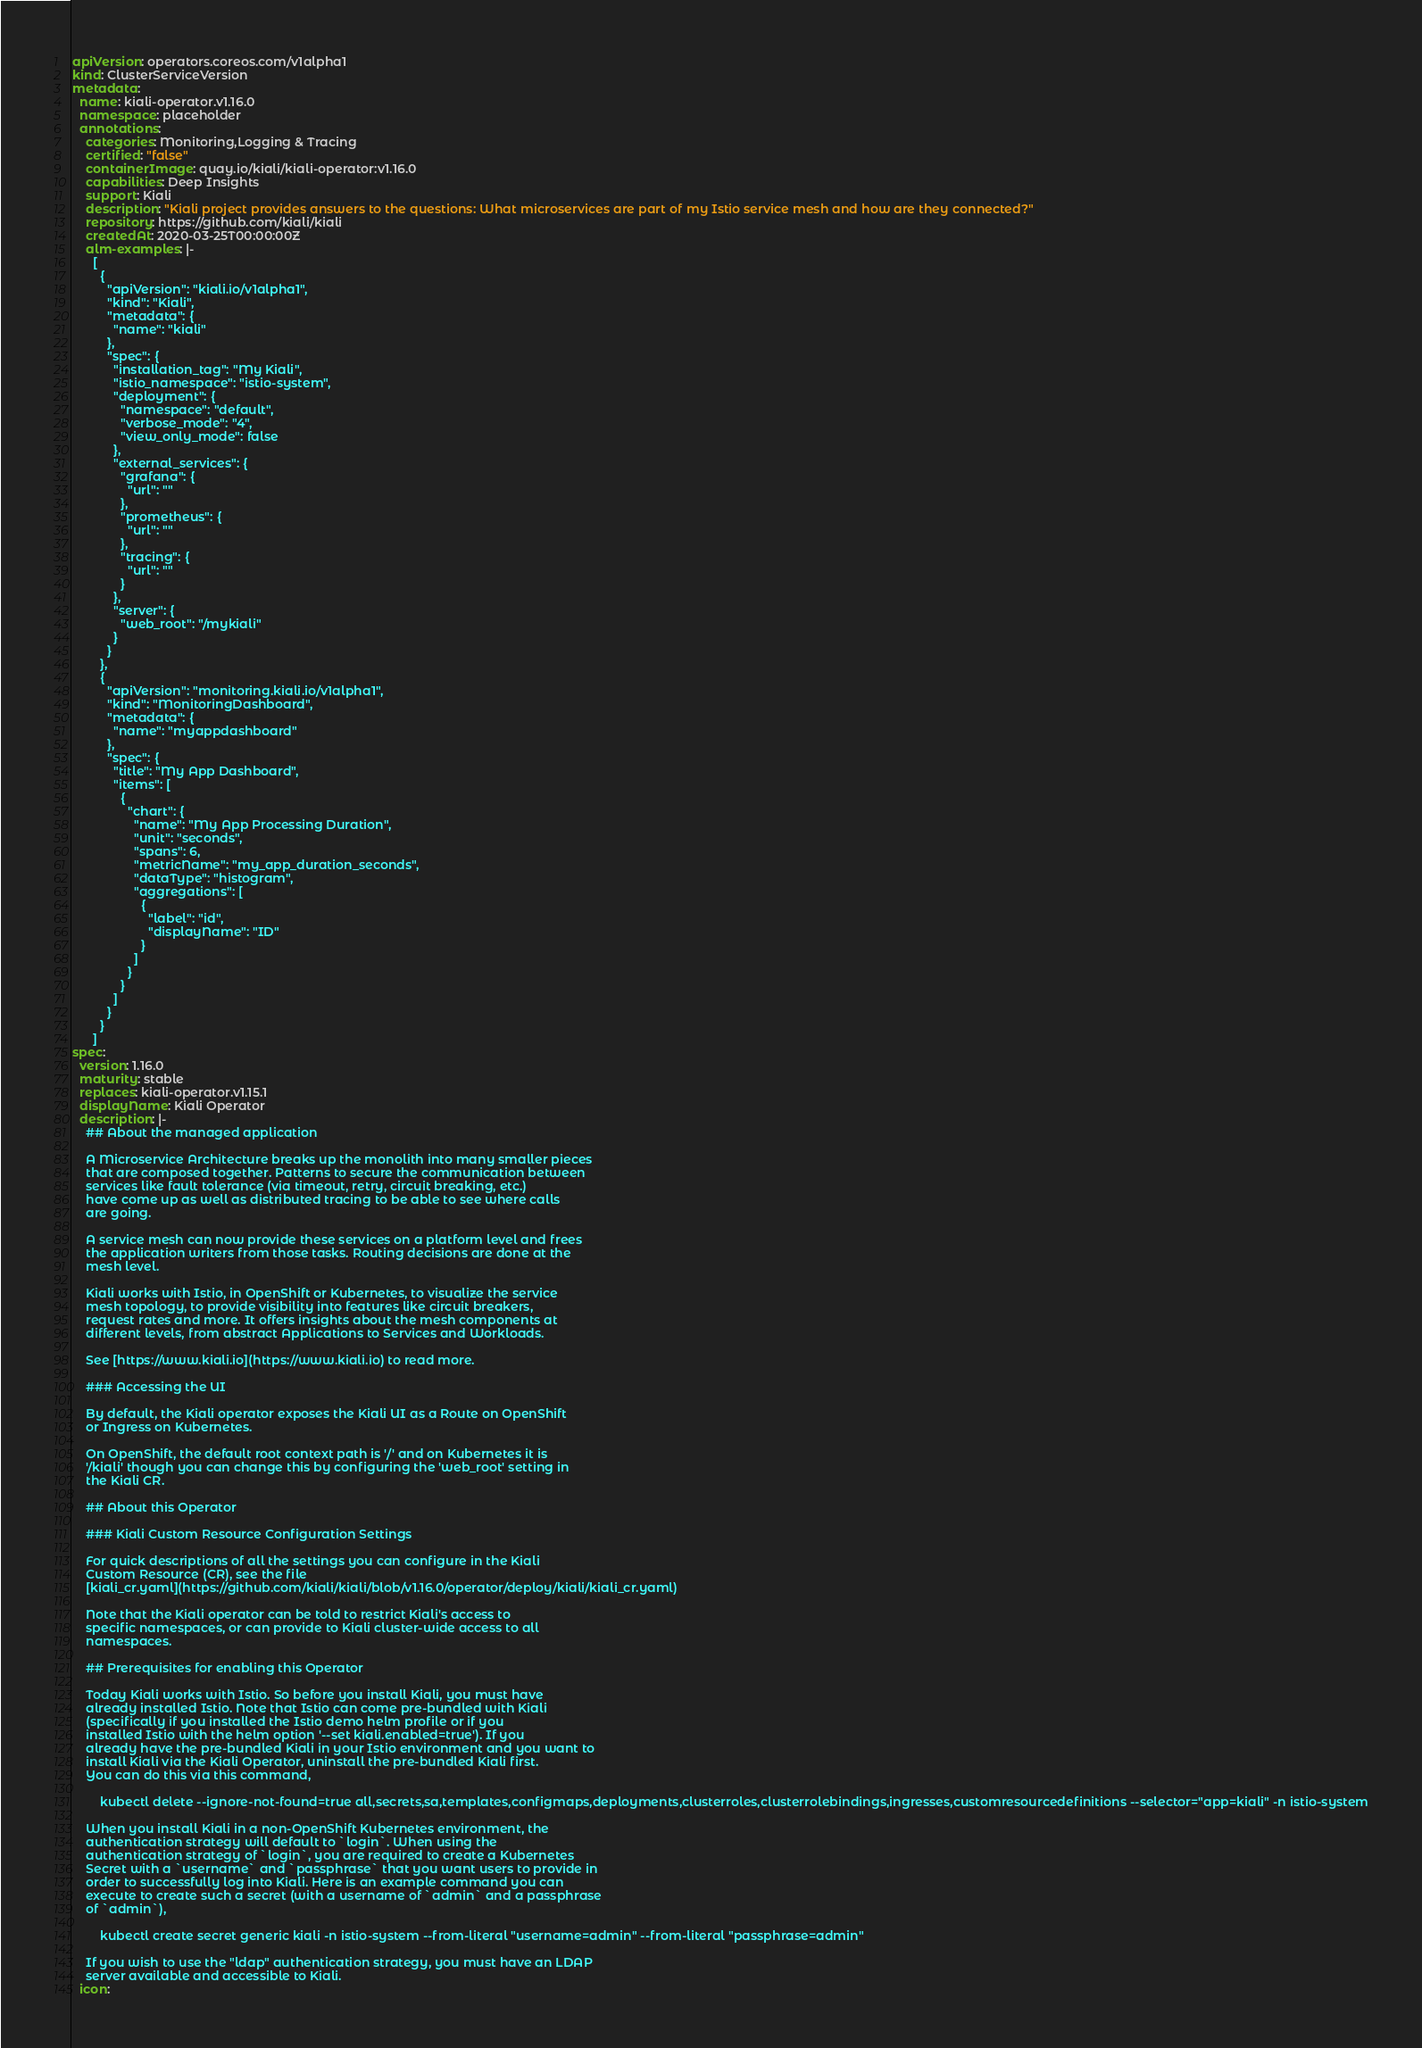Convert code to text. <code><loc_0><loc_0><loc_500><loc_500><_YAML_>apiVersion: operators.coreos.com/v1alpha1
kind: ClusterServiceVersion
metadata:
  name: kiali-operator.v1.16.0
  namespace: placeholder
  annotations:
    categories: Monitoring,Logging & Tracing
    certified: "false"
    containerImage: quay.io/kiali/kiali-operator:v1.16.0
    capabilities: Deep Insights
    support: Kiali
    description: "Kiali project provides answers to the questions: What microservices are part of my Istio service mesh and how are they connected?"
    repository: https://github.com/kiali/kiali
    createdAt: 2020-03-25T00:00:00Z
    alm-examples: |-
      [
        {
          "apiVersion": "kiali.io/v1alpha1",
          "kind": "Kiali",
          "metadata": {
            "name": "kiali"
          },
          "spec": {
            "installation_tag": "My Kiali",
            "istio_namespace": "istio-system",
            "deployment": {
              "namespace": "default",
              "verbose_mode": "4",
              "view_only_mode": false
            },
            "external_services": {
              "grafana": {
                "url": ""
              },
              "prometheus": {
                "url": ""
              },
              "tracing": {
                "url": ""
              }
            },
            "server": {
              "web_root": "/mykiali"
            }
          }
        },
        {
          "apiVersion": "monitoring.kiali.io/v1alpha1",
          "kind": "MonitoringDashboard",
          "metadata": {
            "name": "myappdashboard"
          },
          "spec": {
            "title": "My App Dashboard",
            "items": [
              {
                "chart": {
                  "name": "My App Processing Duration",
                  "unit": "seconds",
                  "spans": 6,
                  "metricName": "my_app_duration_seconds",
                  "dataType": "histogram",
                  "aggregations": [
                    {
                      "label": "id",
                      "displayName": "ID"
                    }
                  ]
                }
              }
            ]
          }
        }
      ]
spec:
  version: 1.16.0
  maturity: stable
  replaces: kiali-operator.v1.15.1
  displayName: Kiali Operator
  description: |-
    ## About the managed application

    A Microservice Architecture breaks up the monolith into many smaller pieces
    that are composed together. Patterns to secure the communication between
    services like fault tolerance (via timeout, retry, circuit breaking, etc.)
    have come up as well as distributed tracing to be able to see where calls
    are going.

    A service mesh can now provide these services on a platform level and frees
    the application writers from those tasks. Routing decisions are done at the
    mesh level.

    Kiali works with Istio, in OpenShift or Kubernetes, to visualize the service
    mesh topology, to provide visibility into features like circuit breakers,
    request rates and more. It offers insights about the mesh components at
    different levels, from abstract Applications to Services and Workloads.

    See [https://www.kiali.io](https://www.kiali.io) to read more.

    ### Accessing the UI

    By default, the Kiali operator exposes the Kiali UI as a Route on OpenShift
    or Ingress on Kubernetes.

    On OpenShift, the default root context path is '/' and on Kubernetes it is
    '/kiali' though you can change this by configuring the 'web_root' setting in
    the Kiali CR.

    ## About this Operator

    ### Kiali Custom Resource Configuration Settings

    For quick descriptions of all the settings you can configure in the Kiali
    Custom Resource (CR), see the file
    [kiali_cr.yaml](https://github.com/kiali/kiali/blob/v1.16.0/operator/deploy/kiali/kiali_cr.yaml)

    Note that the Kiali operator can be told to restrict Kiali's access to
    specific namespaces, or can provide to Kiali cluster-wide access to all
    namespaces.

    ## Prerequisites for enabling this Operator

    Today Kiali works with Istio. So before you install Kiali, you must have
    already installed Istio. Note that Istio can come pre-bundled with Kiali
    (specifically if you installed the Istio demo helm profile or if you
    installed Istio with the helm option '--set kiali.enabled=true'). If you
    already have the pre-bundled Kiali in your Istio environment and you want to
    install Kiali via the Kiali Operator, uninstall the pre-bundled Kiali first.
    You can do this via this command,

        kubectl delete --ignore-not-found=true all,secrets,sa,templates,configmaps,deployments,clusterroles,clusterrolebindings,ingresses,customresourcedefinitions --selector="app=kiali" -n istio-system

    When you install Kiali in a non-OpenShift Kubernetes environment, the
    authentication strategy will default to `login`. When using the
    authentication strategy of `login`, you are required to create a Kubernetes
    Secret with a `username` and `passphrase` that you want users to provide in
    order to successfully log into Kiali. Here is an example command you can
    execute to create such a secret (with a username of `admin` and a passphrase
    of `admin`),

        kubectl create secret generic kiali -n istio-system --from-literal "username=admin" --from-literal "passphrase=admin"

    If you wish to use the "ldap" authentication strategy, you must have an LDAP
    server available and accessible to Kiali.
  icon:</code> 